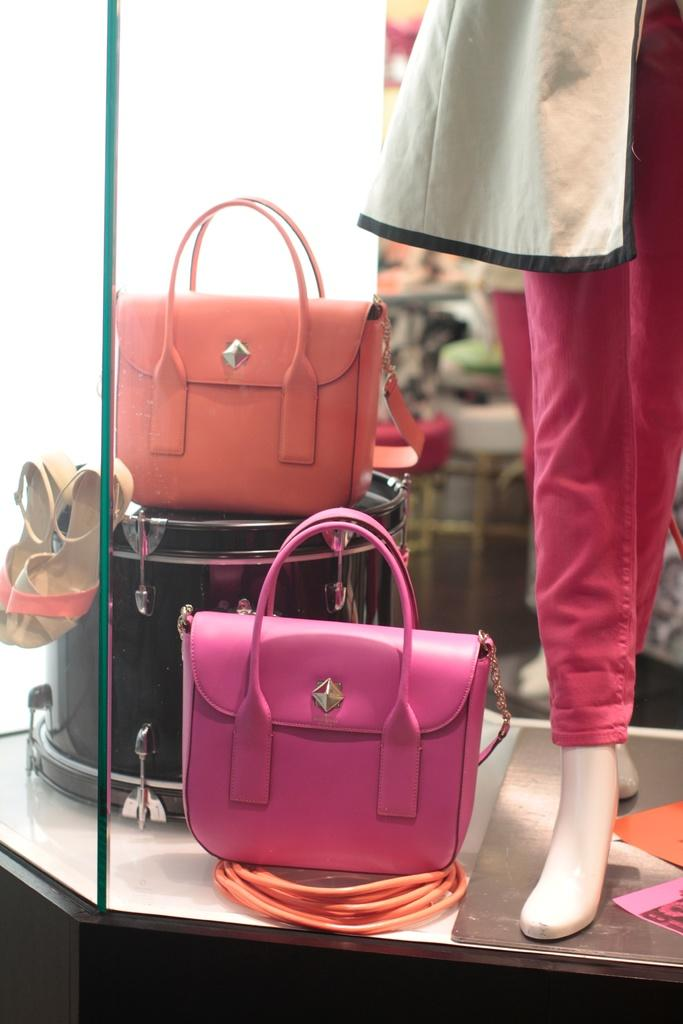What colors are the handbags in the image? There is a pink handbag and an orange handbag in the image. What type of footwear is visible in the image? There is a pair of sandals in the image. What is the mannequin wearing in the image? The mannequin is wearing a pink pant. What is the mannequin holding or interacting with in the image? The mannequin is not holding or interacting with any object in the image. Who is the daughter of the mannequin in the image? There is no daughter present in the image, as the mannequin is an inanimate object. What type of utensil is the fork in the image? There is no fork present in the image. 